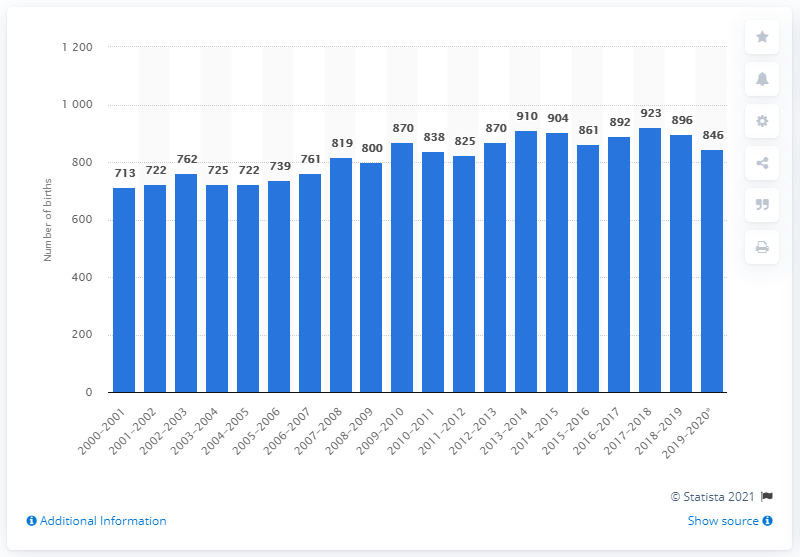List a handful of essential elements in this visual. Between July 1, 2019 and June 30, 2020, a total of 846 people were born in Nunavut. 